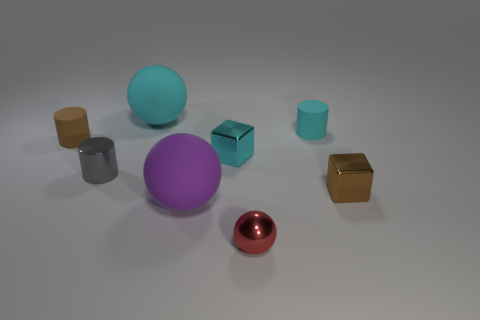Subtract all red metallic balls. How many balls are left? 2 Subtract 1 cylinders. How many cylinders are left? 2 Add 1 big yellow objects. How many objects exist? 9 Subtract all cubes. How many objects are left? 6 Subtract all blue cylinders. Subtract all green cubes. How many cylinders are left? 3 Subtract 0 purple cubes. How many objects are left? 8 Subtract all tiny cyan matte objects. Subtract all brown shiny blocks. How many objects are left? 6 Add 6 brown objects. How many brown objects are left? 8 Add 4 gray rubber spheres. How many gray rubber spheres exist? 4 